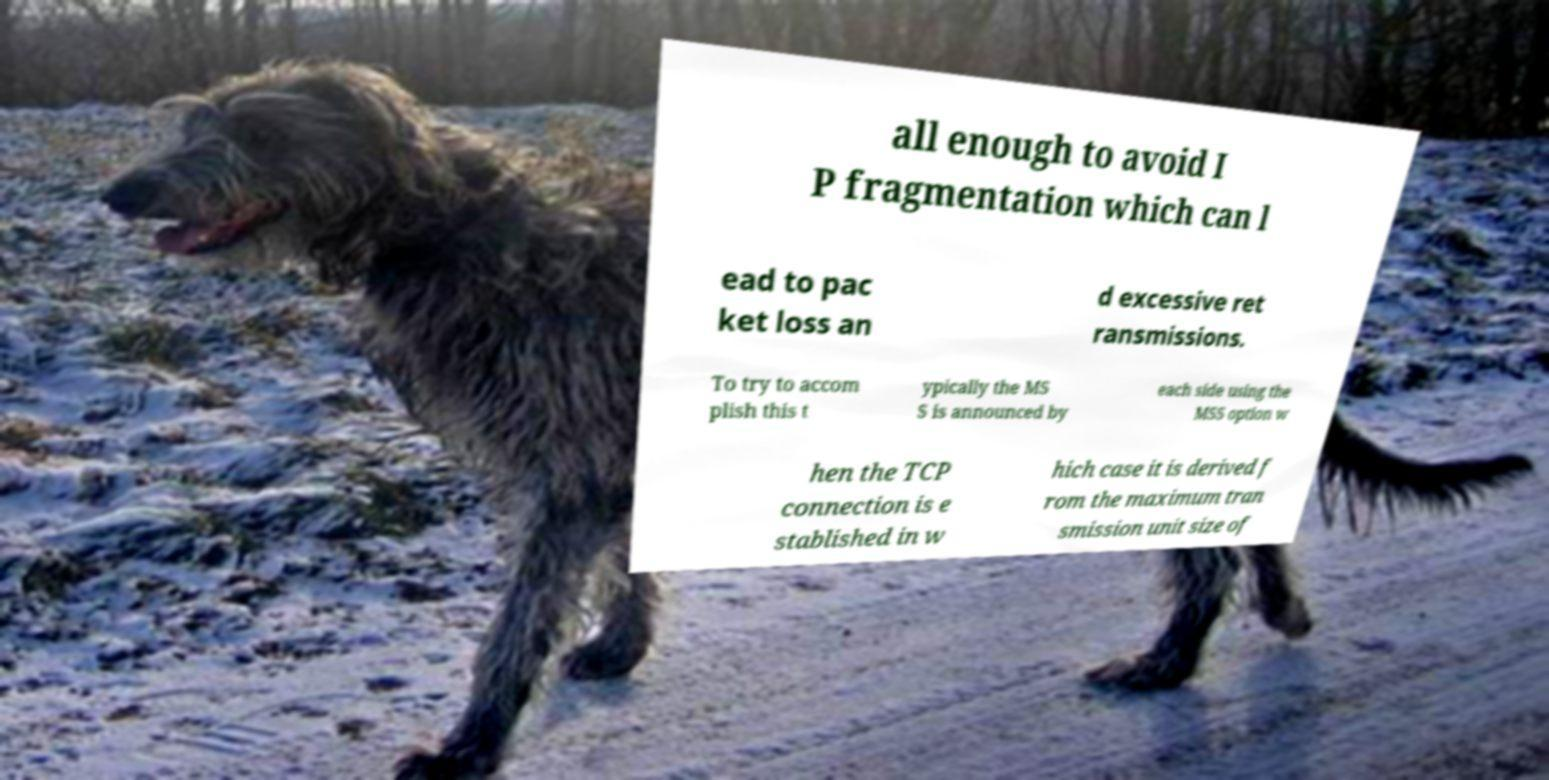What messages or text are displayed in this image? I need them in a readable, typed format. all enough to avoid I P fragmentation which can l ead to pac ket loss an d excessive ret ransmissions. To try to accom plish this t ypically the MS S is announced by each side using the MSS option w hen the TCP connection is e stablished in w hich case it is derived f rom the maximum tran smission unit size of 